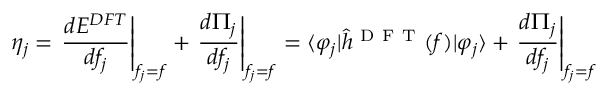Convert formula to latex. <formula><loc_0><loc_0><loc_500><loc_500>\eta _ { j } = \frac { d E ^ { D F T } } { d f _ { j } } \right | _ { f _ { j } = f } + \frac { d \Pi _ { j } } { d f _ { j } } \right | _ { f _ { j } = f } = \langle \varphi _ { j } | \hat { h } ^ { D F T } ( f ) | \varphi _ { j } \rangle + \frac { d \Pi _ { j } } { d f _ { j } } \right | _ { f _ { j } = f }</formula> 